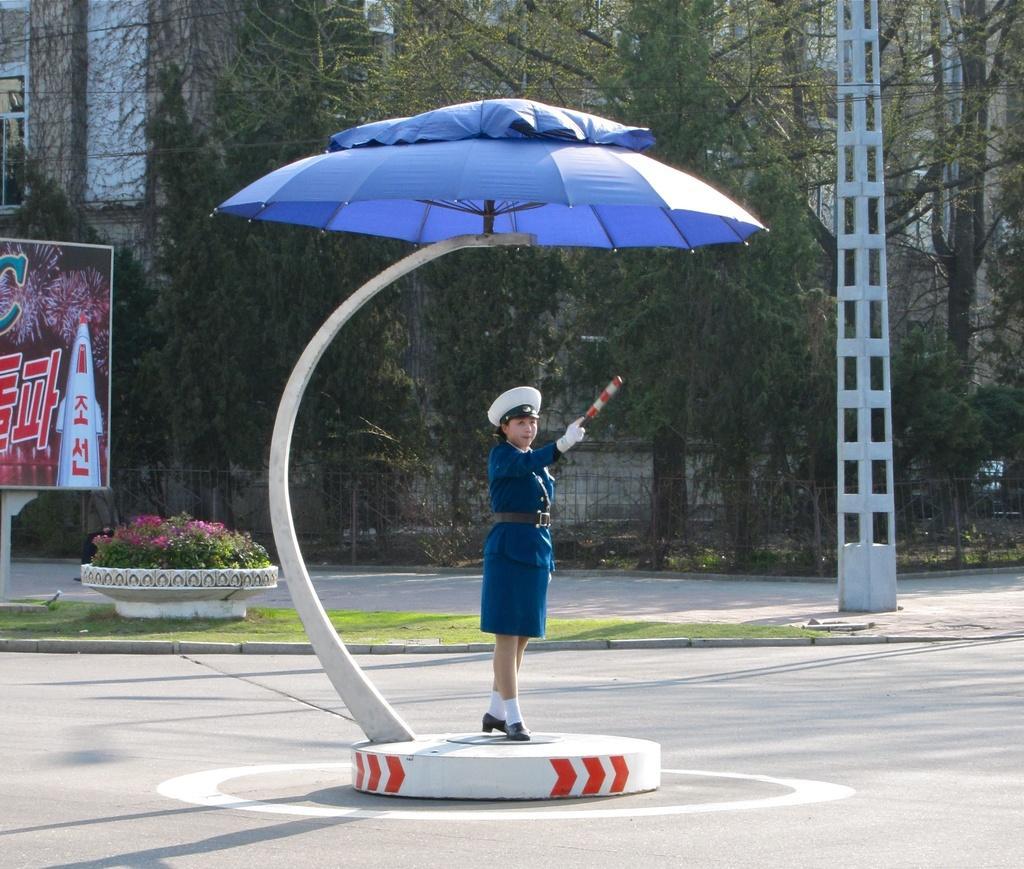Please provide a concise description of this image. As we can see in the image there is a banner, plants, grass, a woman standing over here, current pole, trees and there is a building. 